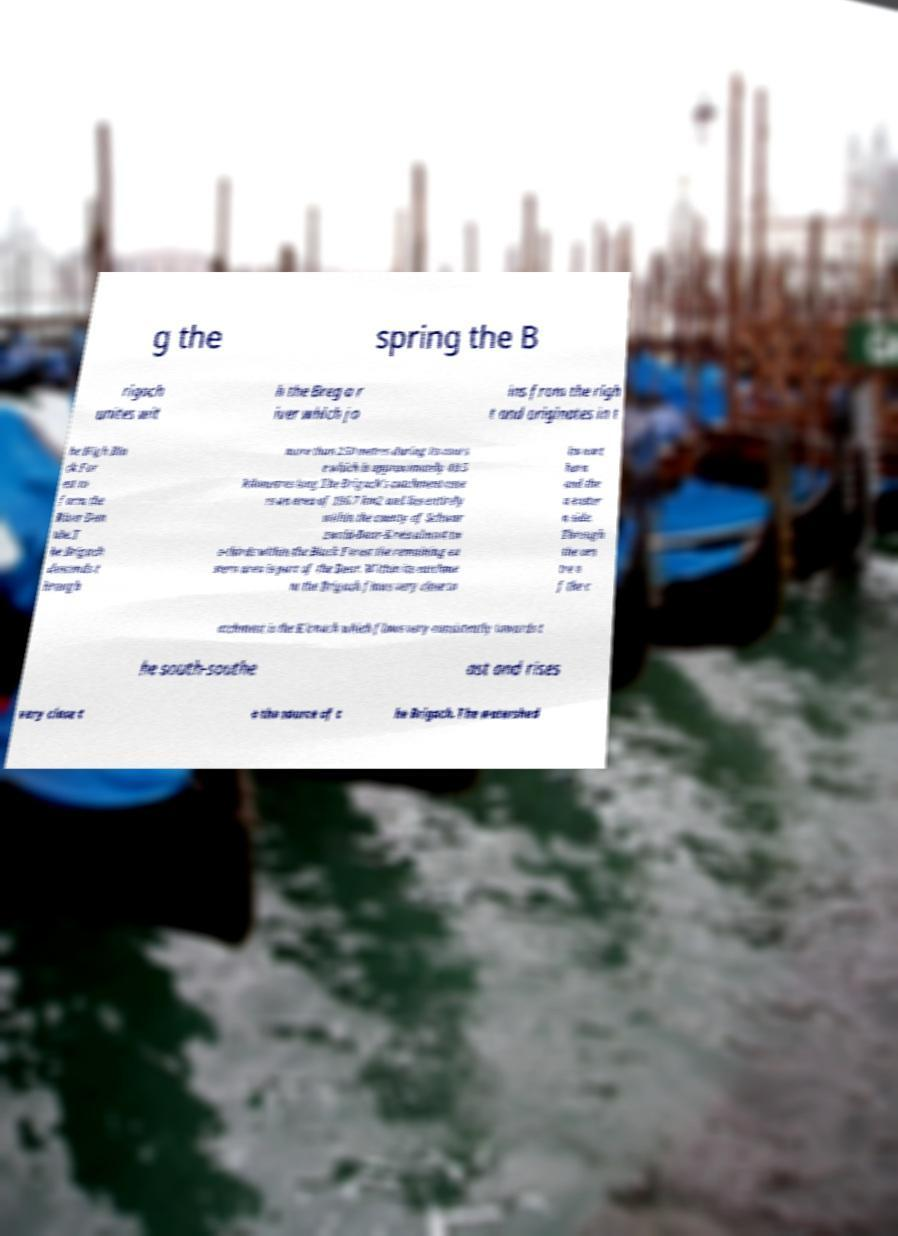I need the written content from this picture converted into text. Can you do that? g the spring the B rigach unites wit h the Breg a r iver which jo ins from the righ t and originates in t he High Bla ck For est to form the River Dan ube.T he Brigach descends t hrough more than 250 metres during its cours e which is approximately 40.5 kilometres long.The Brigach's catchment cove rs an area of 196.7 km2 and lies entirely within the county of Schwar zwald-Baar-Kreis almost tw o-thirds within the Black Forest the remaining ea stern area is part of the Baar. Within its catchme nt the Brigach flows very close to its nort hern and the n easter n side. Through the cen tre o f the c atchment is the Kirnach which flows very consistently towards t he south-southe ast and rises very close t o the source of t he Brigach. The watershed 